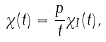Convert formula to latex. <formula><loc_0><loc_0><loc_500><loc_500>\chi ( t ) = \frac { p } { t } \chi _ { I } ( t ) ,</formula> 